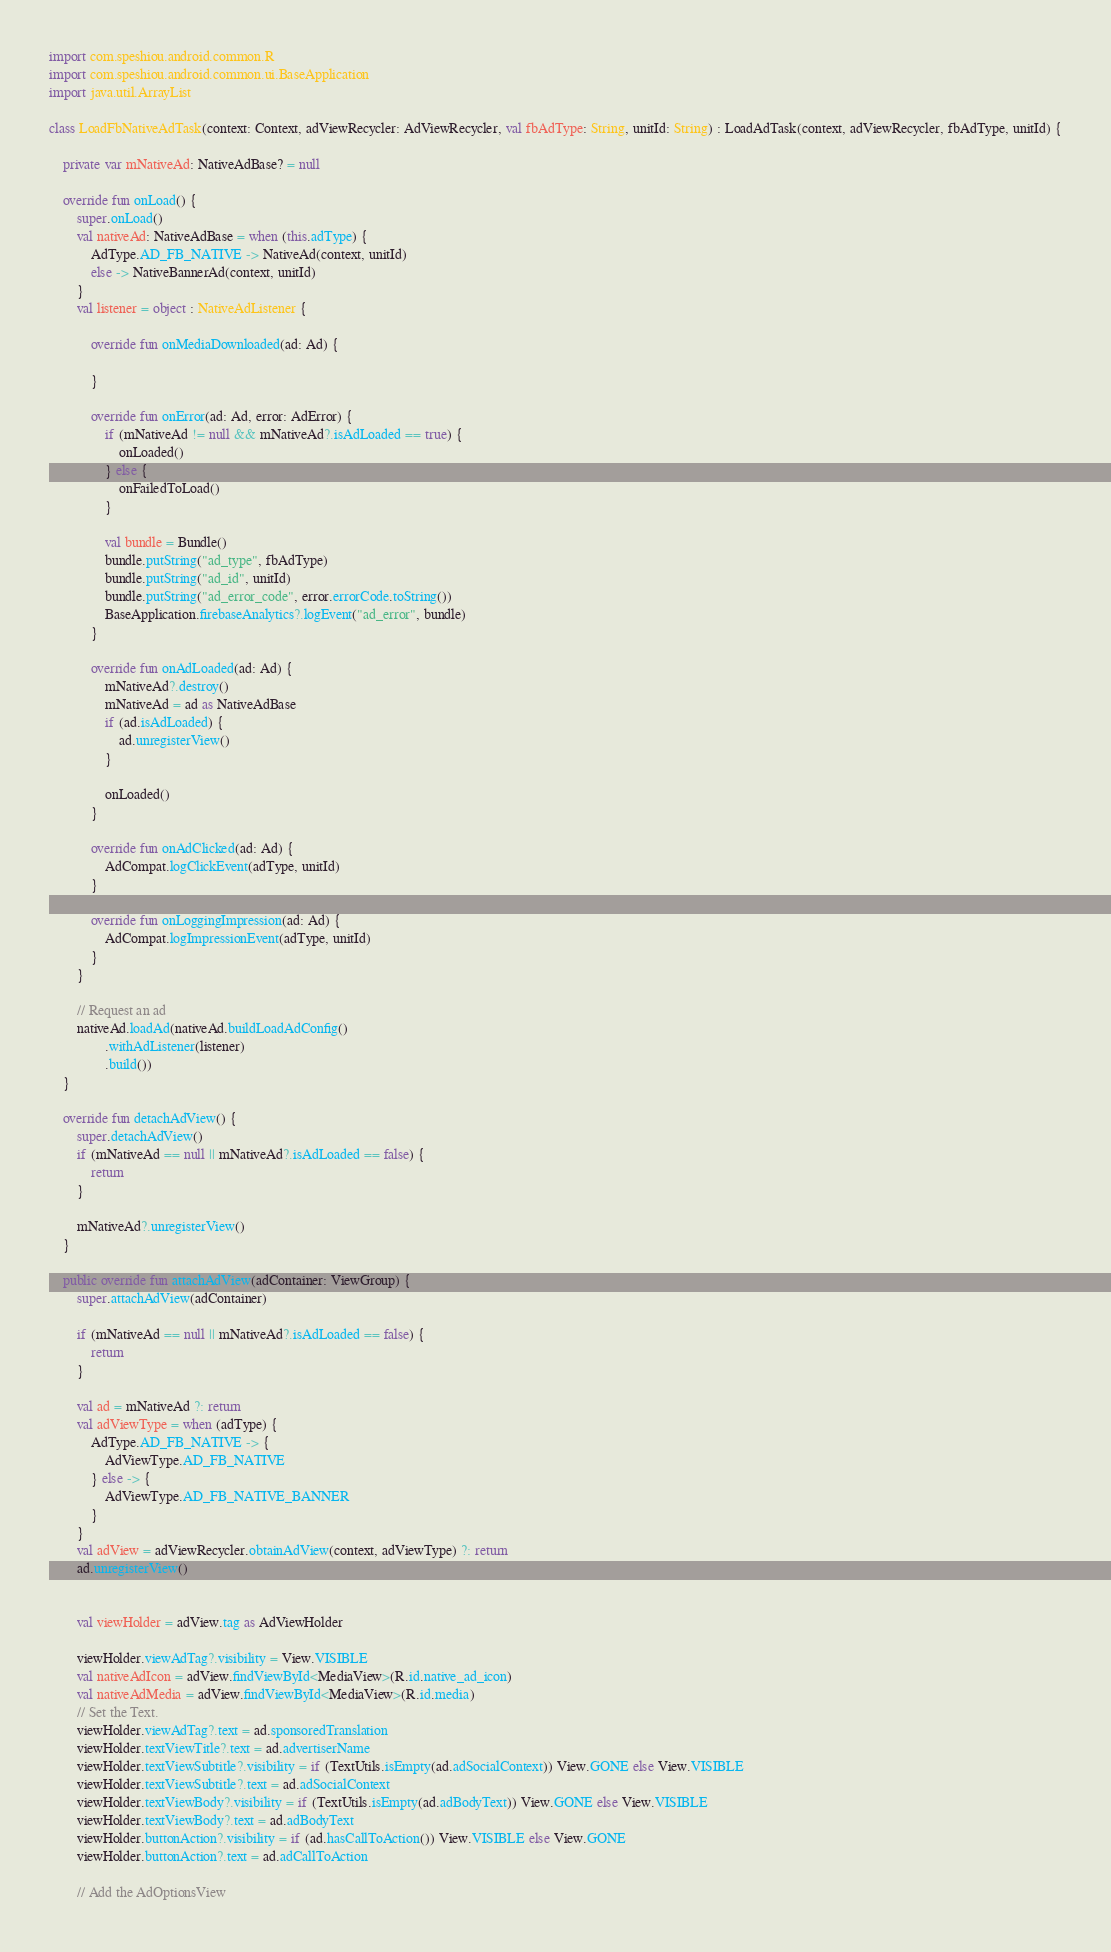Convert code to text. <code><loc_0><loc_0><loc_500><loc_500><_Kotlin_>import com.speshiou.android.common.R
import com.speshiou.android.common.ui.BaseApplication
import java.util.ArrayList

class LoadFbNativeAdTask(context: Context, adViewRecycler: AdViewRecycler, val fbAdType: String, unitId: String) : LoadAdTask(context, adViewRecycler, fbAdType, unitId) {

    private var mNativeAd: NativeAdBase? = null

    override fun onLoad() {
        super.onLoad()
        val nativeAd: NativeAdBase = when (this.adType) {
            AdType.AD_FB_NATIVE -> NativeAd(context, unitId)
            else -> NativeBannerAd(context, unitId)
        }
        val listener = object : NativeAdListener {

            override fun onMediaDownloaded(ad: Ad) {

            }

            override fun onError(ad: Ad, error: AdError) {
                if (mNativeAd != null && mNativeAd?.isAdLoaded == true) {
                    onLoaded()
                } else {
                    onFailedToLoad()
                }

                val bundle = Bundle()
                bundle.putString("ad_type", fbAdType)
                bundle.putString("ad_id", unitId)
                bundle.putString("ad_error_code", error.errorCode.toString())
                BaseApplication.firebaseAnalytics?.logEvent("ad_error", bundle)
            }

            override fun onAdLoaded(ad: Ad) {
                mNativeAd?.destroy()
                mNativeAd = ad as NativeAdBase
                if (ad.isAdLoaded) {
                    ad.unregisterView()
                }

                onLoaded()
            }

            override fun onAdClicked(ad: Ad) {
                AdCompat.logClickEvent(adType, unitId)
            }

            override fun onLoggingImpression(ad: Ad) {
                AdCompat.logImpressionEvent(adType, unitId)
            }
        }

        // Request an ad
        nativeAd.loadAd(nativeAd.buildLoadAdConfig()
                .withAdListener(listener)
                .build())
    }

    override fun detachAdView() {
        super.detachAdView()
        if (mNativeAd == null || mNativeAd?.isAdLoaded == false) {
            return
        }

        mNativeAd?.unregisterView()
    }

    public override fun attachAdView(adContainer: ViewGroup) {
        super.attachAdView(adContainer)

        if (mNativeAd == null || mNativeAd?.isAdLoaded == false) {
            return
        }

        val ad = mNativeAd ?: return
        val adViewType = when (adType) {
            AdType.AD_FB_NATIVE -> {
                AdViewType.AD_FB_NATIVE
            } else -> {
                AdViewType.AD_FB_NATIVE_BANNER
            }
        }
        val adView = adViewRecycler.obtainAdView(context, adViewType) ?: return
        ad.unregisterView()


        val viewHolder = adView.tag as AdViewHolder

        viewHolder.viewAdTag?.visibility = View.VISIBLE
        val nativeAdIcon = adView.findViewById<MediaView>(R.id.native_ad_icon)
        val nativeAdMedia = adView.findViewById<MediaView>(R.id.media)
        // Set the Text.
        viewHolder.viewAdTag?.text = ad.sponsoredTranslation
        viewHolder.textViewTitle?.text = ad.advertiserName
        viewHolder.textViewSubtitle?.visibility = if (TextUtils.isEmpty(ad.adSocialContext)) View.GONE else View.VISIBLE
        viewHolder.textViewSubtitle?.text = ad.adSocialContext
        viewHolder.textViewBody?.visibility = if (TextUtils.isEmpty(ad.adBodyText)) View.GONE else View.VISIBLE
        viewHolder.textViewBody?.text = ad.adBodyText
        viewHolder.buttonAction?.visibility = if (ad.hasCallToAction()) View.VISIBLE else View.GONE
        viewHolder.buttonAction?.text = ad.adCallToAction

        // Add the AdOptionsView</code> 